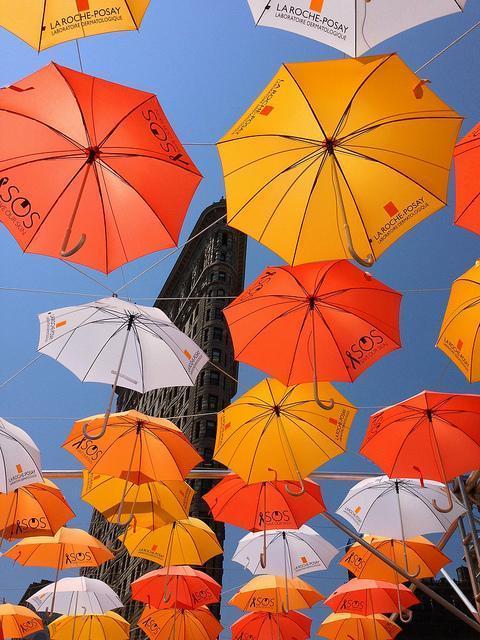How many umbrellas can be seen?
Give a very brief answer. 13. 